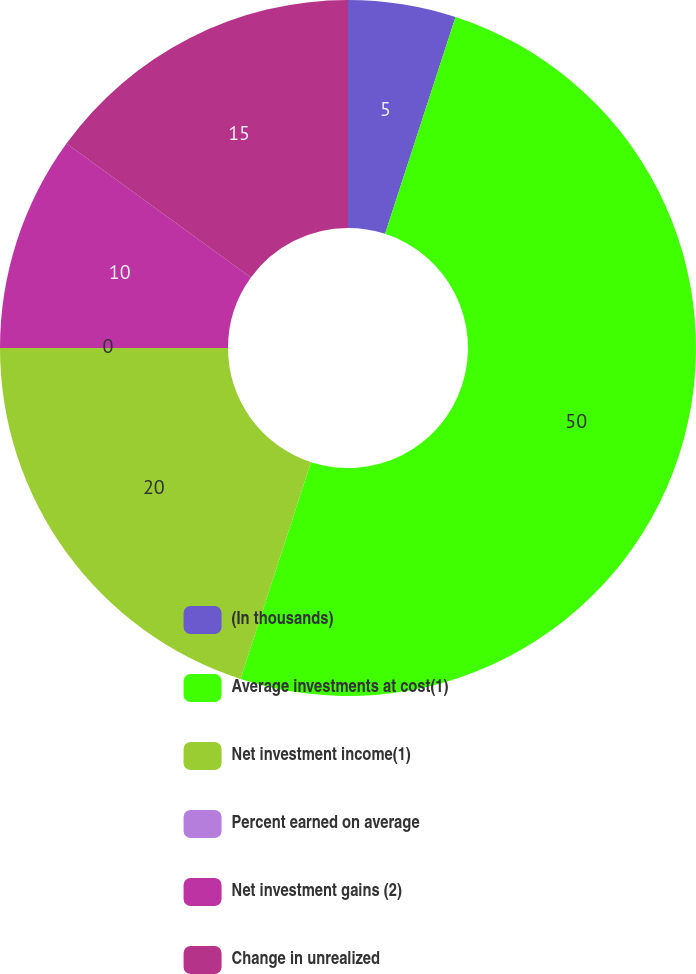Convert chart. <chart><loc_0><loc_0><loc_500><loc_500><pie_chart><fcel>(In thousands)<fcel>Average investments at cost(1)<fcel>Net investment income(1)<fcel>Percent earned on average<fcel>Net investment gains (2)<fcel>Change in unrealized<nl><fcel>5.0%<fcel>50.0%<fcel>20.0%<fcel>0.0%<fcel>10.0%<fcel>15.0%<nl></chart> 